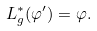Convert formula to latex. <formula><loc_0><loc_0><loc_500><loc_500>L _ { g } ^ { * } ( \varphi ^ { \prime } ) = \varphi .</formula> 